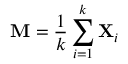Convert formula to latex. <formula><loc_0><loc_0><loc_500><loc_500>M = { \frac { 1 } { k } } \sum _ { i = 1 } ^ { k } X _ { i }</formula> 